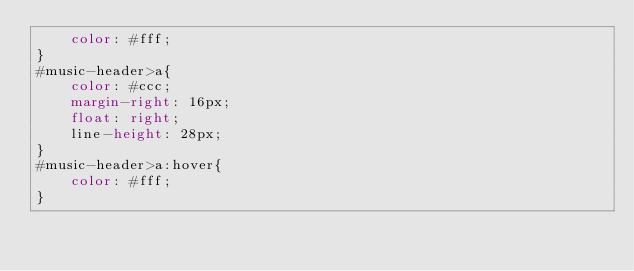Convert code to text. <code><loc_0><loc_0><loc_500><loc_500><_CSS_>    color: #fff;
}
#music-header>a{
    color: #ccc;
    margin-right: 16px;
    float: right;
    line-height: 28px;
}
#music-header>a:hover{
    color: #fff;
}</code> 